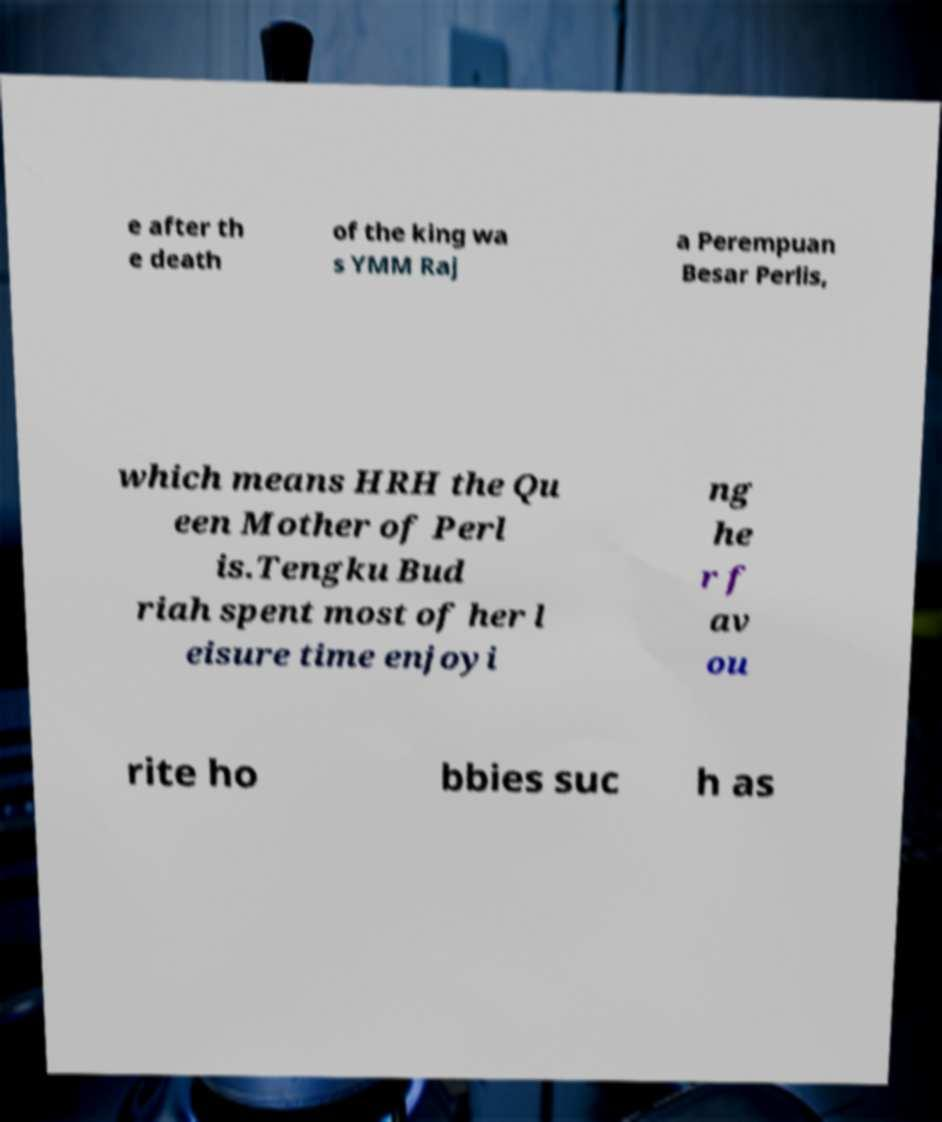I need the written content from this picture converted into text. Can you do that? e after th e death of the king wa s YMM Raj a Perempuan Besar Perlis, which means HRH the Qu een Mother of Perl is.Tengku Bud riah spent most of her l eisure time enjoyi ng he r f av ou rite ho bbies suc h as 